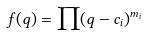<formula> <loc_0><loc_0><loc_500><loc_500>f ( q ) = \prod ( q - c _ { i } ) ^ { m _ { i } }</formula> 